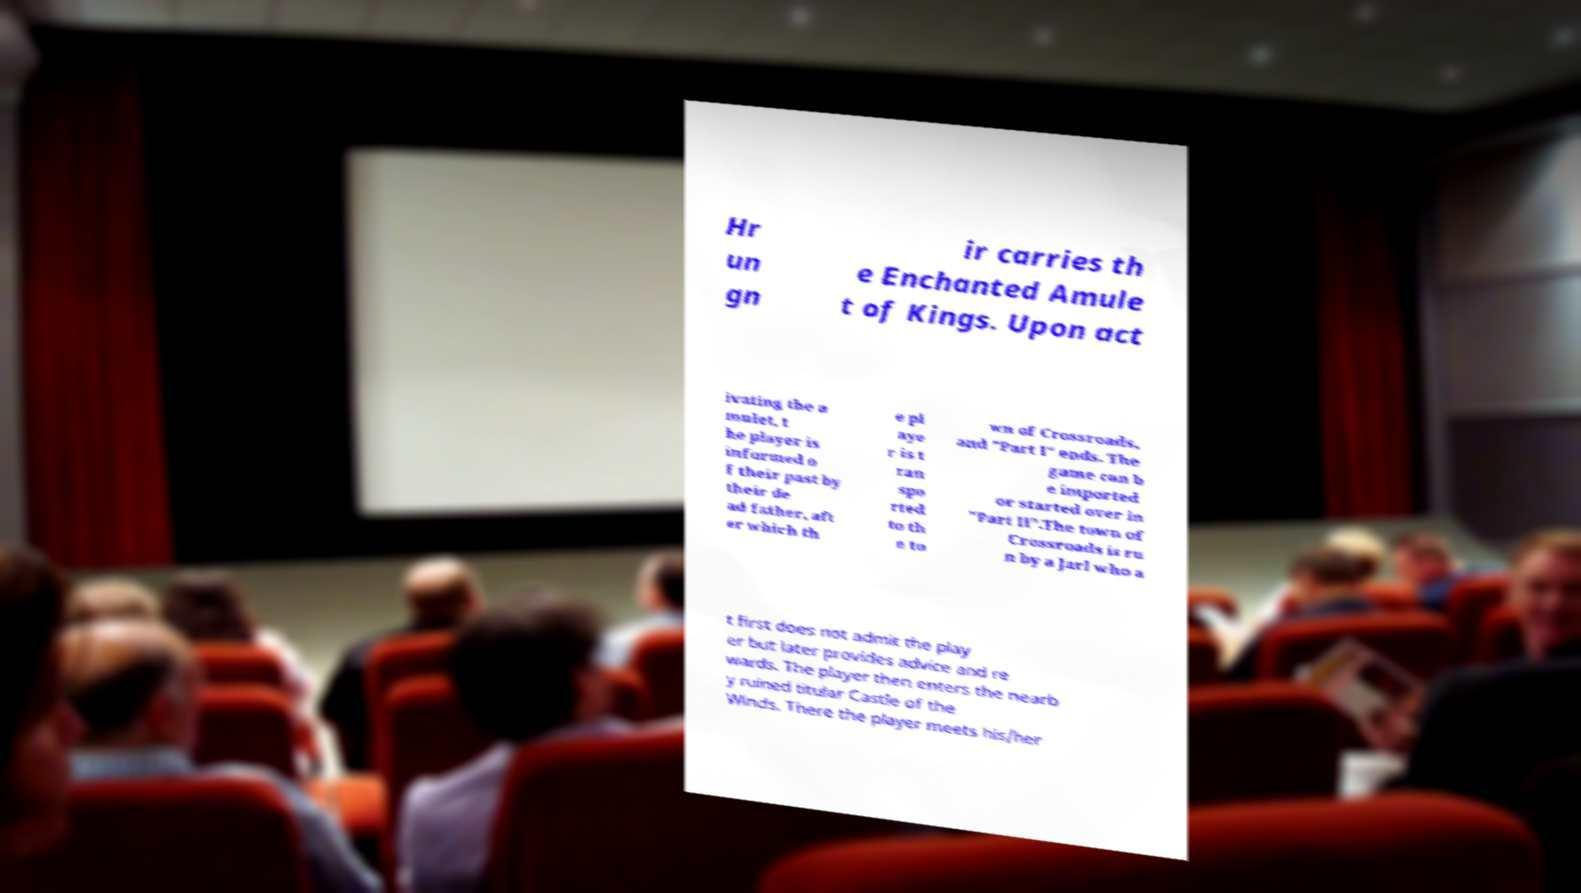Please read and relay the text visible in this image. What does it say? Hr un gn ir carries th e Enchanted Amule t of Kings. Upon act ivating the a mulet, t he player is informed o f their past by their de ad father, aft er which th e pl aye r is t ran spo rted to th e to wn of Crossroads, and "Part I" ends. The game can b e imported or started over in "Part II".The town of Crossroads is ru n by a Jarl who a t first does not admit the play er but later provides advice and re wards. The player then enters the nearb y ruined titular Castle of the Winds. There the player meets his/her 